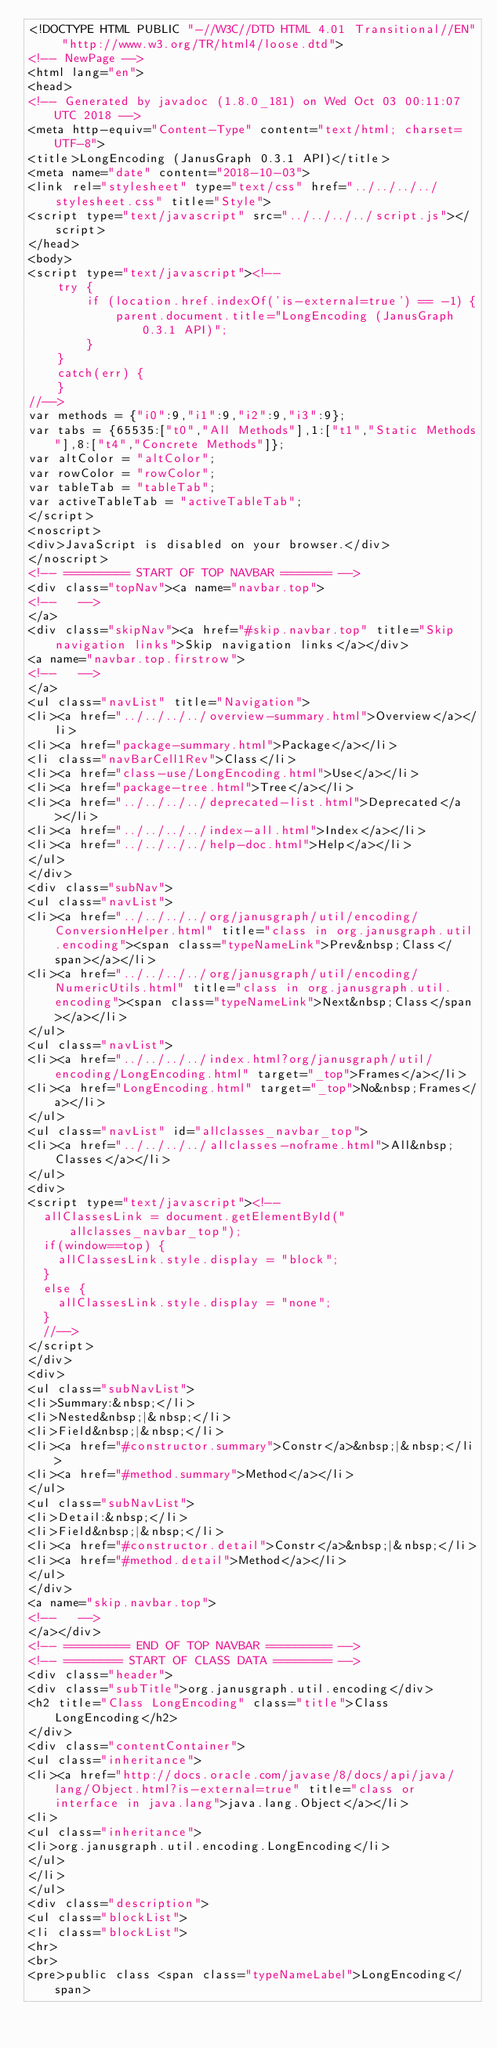Convert code to text. <code><loc_0><loc_0><loc_500><loc_500><_HTML_><!DOCTYPE HTML PUBLIC "-//W3C//DTD HTML 4.01 Transitional//EN" "http://www.w3.org/TR/html4/loose.dtd">
<!-- NewPage -->
<html lang="en">
<head>
<!-- Generated by javadoc (1.8.0_181) on Wed Oct 03 00:11:07 UTC 2018 -->
<meta http-equiv="Content-Type" content="text/html; charset=UTF-8">
<title>LongEncoding (JanusGraph 0.3.1 API)</title>
<meta name="date" content="2018-10-03">
<link rel="stylesheet" type="text/css" href="../../../../stylesheet.css" title="Style">
<script type="text/javascript" src="../../../../script.js"></script>
</head>
<body>
<script type="text/javascript"><!--
    try {
        if (location.href.indexOf('is-external=true') == -1) {
            parent.document.title="LongEncoding (JanusGraph 0.3.1 API)";
        }
    }
    catch(err) {
    }
//-->
var methods = {"i0":9,"i1":9,"i2":9,"i3":9};
var tabs = {65535:["t0","All Methods"],1:["t1","Static Methods"],8:["t4","Concrete Methods"]};
var altColor = "altColor";
var rowColor = "rowColor";
var tableTab = "tableTab";
var activeTableTab = "activeTableTab";
</script>
<noscript>
<div>JavaScript is disabled on your browser.</div>
</noscript>
<!-- ========= START OF TOP NAVBAR ======= -->
<div class="topNav"><a name="navbar.top">
<!--   -->
</a>
<div class="skipNav"><a href="#skip.navbar.top" title="Skip navigation links">Skip navigation links</a></div>
<a name="navbar.top.firstrow">
<!--   -->
</a>
<ul class="navList" title="Navigation">
<li><a href="../../../../overview-summary.html">Overview</a></li>
<li><a href="package-summary.html">Package</a></li>
<li class="navBarCell1Rev">Class</li>
<li><a href="class-use/LongEncoding.html">Use</a></li>
<li><a href="package-tree.html">Tree</a></li>
<li><a href="../../../../deprecated-list.html">Deprecated</a></li>
<li><a href="../../../../index-all.html">Index</a></li>
<li><a href="../../../../help-doc.html">Help</a></li>
</ul>
</div>
<div class="subNav">
<ul class="navList">
<li><a href="../../../../org/janusgraph/util/encoding/ConversionHelper.html" title="class in org.janusgraph.util.encoding"><span class="typeNameLink">Prev&nbsp;Class</span></a></li>
<li><a href="../../../../org/janusgraph/util/encoding/NumericUtils.html" title="class in org.janusgraph.util.encoding"><span class="typeNameLink">Next&nbsp;Class</span></a></li>
</ul>
<ul class="navList">
<li><a href="../../../../index.html?org/janusgraph/util/encoding/LongEncoding.html" target="_top">Frames</a></li>
<li><a href="LongEncoding.html" target="_top">No&nbsp;Frames</a></li>
</ul>
<ul class="navList" id="allclasses_navbar_top">
<li><a href="../../../../allclasses-noframe.html">All&nbsp;Classes</a></li>
</ul>
<div>
<script type="text/javascript"><!--
  allClassesLink = document.getElementById("allclasses_navbar_top");
  if(window==top) {
    allClassesLink.style.display = "block";
  }
  else {
    allClassesLink.style.display = "none";
  }
  //-->
</script>
</div>
<div>
<ul class="subNavList">
<li>Summary:&nbsp;</li>
<li>Nested&nbsp;|&nbsp;</li>
<li>Field&nbsp;|&nbsp;</li>
<li><a href="#constructor.summary">Constr</a>&nbsp;|&nbsp;</li>
<li><a href="#method.summary">Method</a></li>
</ul>
<ul class="subNavList">
<li>Detail:&nbsp;</li>
<li>Field&nbsp;|&nbsp;</li>
<li><a href="#constructor.detail">Constr</a>&nbsp;|&nbsp;</li>
<li><a href="#method.detail">Method</a></li>
</ul>
</div>
<a name="skip.navbar.top">
<!--   -->
</a></div>
<!-- ========= END OF TOP NAVBAR ========= -->
<!-- ======== START OF CLASS DATA ======== -->
<div class="header">
<div class="subTitle">org.janusgraph.util.encoding</div>
<h2 title="Class LongEncoding" class="title">Class LongEncoding</h2>
</div>
<div class="contentContainer">
<ul class="inheritance">
<li><a href="http://docs.oracle.com/javase/8/docs/api/java/lang/Object.html?is-external=true" title="class or interface in java.lang">java.lang.Object</a></li>
<li>
<ul class="inheritance">
<li>org.janusgraph.util.encoding.LongEncoding</li>
</ul>
</li>
</ul>
<div class="description">
<ul class="blockList">
<li class="blockList">
<hr>
<br>
<pre>public class <span class="typeNameLabel">LongEncoding</span></code> 